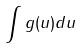Convert formula to latex. <formula><loc_0><loc_0><loc_500><loc_500>\int g ( u ) d u</formula> 